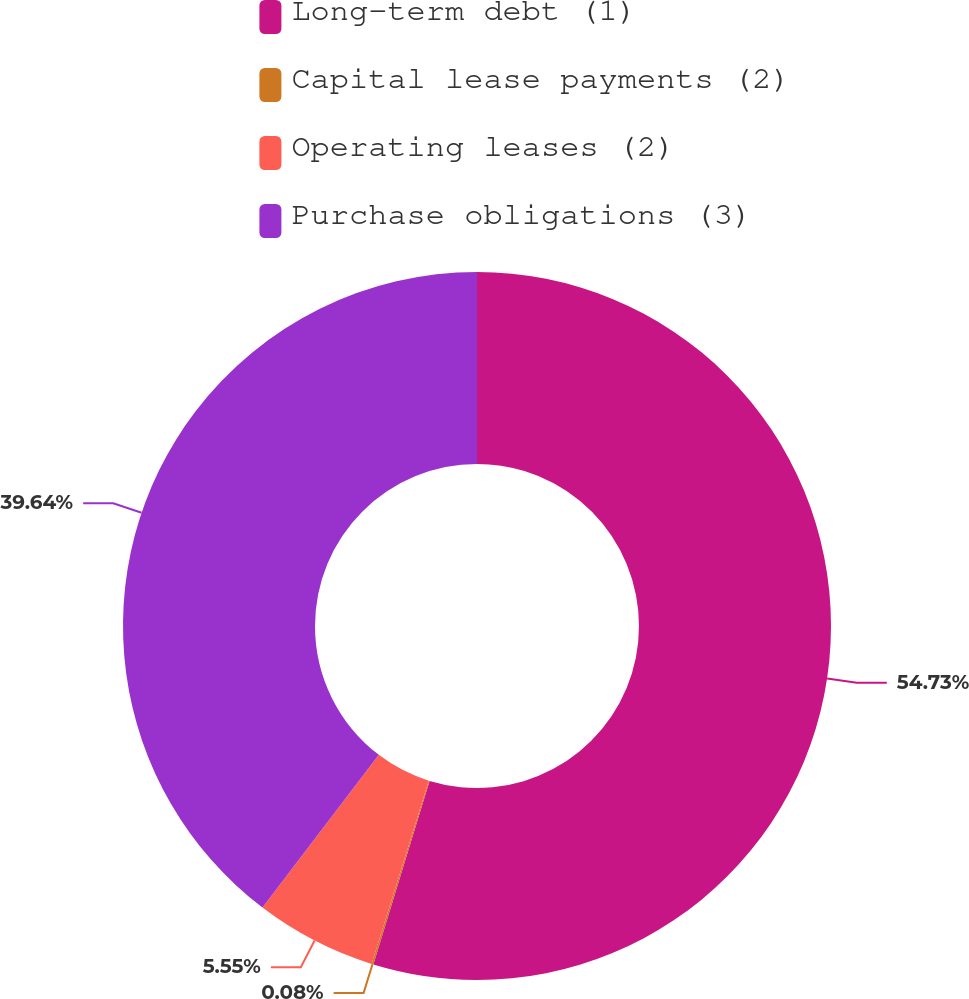Convert chart. <chart><loc_0><loc_0><loc_500><loc_500><pie_chart><fcel>Long-term debt (1)<fcel>Capital lease payments (2)<fcel>Operating leases (2)<fcel>Purchase obligations (3)<nl><fcel>54.73%<fcel>0.08%<fcel>5.55%<fcel>39.64%<nl></chart> 